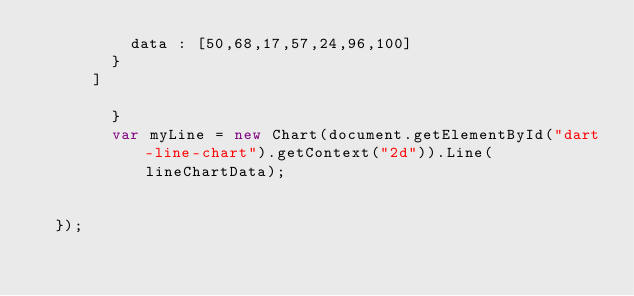Convert code to text. <code><loc_0><loc_0><loc_500><loc_500><_JavaScript_>					data : [50,68,17,57,24,96,100]
				}
			]
		
        }
        var myLine = new Chart(document.getElementById("dart-line-chart").getContext("2d")).Line(lineChartData);
		
			
	});


</code> 